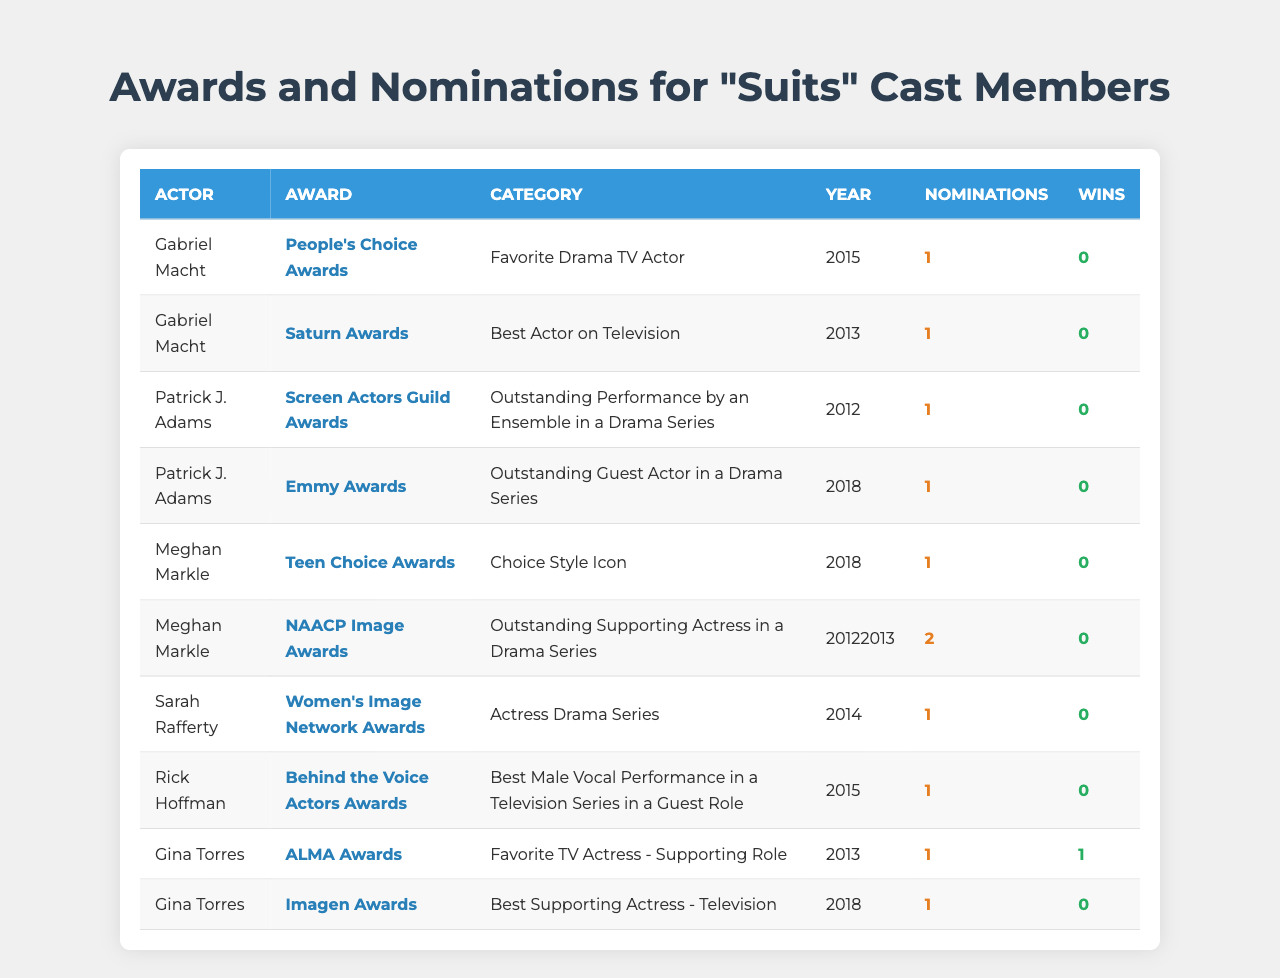What awards did Gabriel Macht receive nominations for? The table lists two awards for which Gabriel Macht received nominations: People's Choice Awards in 2015 for "Favorite Drama TV Actor" and Saturn Awards in 2013 for "Best Actor on Television."
Answer: People's Choice Awards, Saturn Awards How many total nominations did Meghan Markle receive? Meghan Markle received a total of 3 nominations: 1 from the Teen Choice Awards in 2018 and 2 from the NAACP Image Awards in 2012 and 2013. Thus, 1 + 2 = 3.
Answer: 3 Did any of the "Suits" cast members win an award? Yes, Gina Torres won 1 award from the ALMA Awards in 2013 for "Favorite TV Actress - Supporting Role."
Answer: Yes Which actor has the most awards listed in the table? Currently, only Gina Torres has 1 win, while all others have 0 wins. Thus, she has the most awards listed in the table even though it's only 1 win.
Answer: Gina Torres What is the average number of wins among the "Suits" cast members? All cast members except Gina Torres have 0 wins. As we count, there are a total of 7 awards listed, and the total win count is 1. Therefore, 1 win divided by 6 members equals an average of 1/6.
Answer: 0.17 How many years did Meghan Markle get nominated for the NAACP Image Awards? Meghan Markle received 2 nominations for the NAACP Image Awards in the years 2012 and 2013. Hence, she was nominated for a total of 2 years at this award.
Answer: 2 Which award did Rick Hoffman receive a nomination for in 2015? According to the table, Rick Hoffman received a nomination for the Behind the Voice Actors Awards for "Best Male Vocal Performance in a Television Series in a Guest Role" in 2015.
Answer: Behind the Voice Actors Awards Which actor had a nomination in 2014 and for what award? Sarah Rafferty had a nomination in 2014 at the Women's Image Network Awards for "Actress Drama Series." Therefore, she is the actor listed with a nomination in that year.
Answer: Sarah Rafferty, Women's Image Network Awards What is the difference in the number of nominations between Patrick J. Adams and Gabriel Macht? Both actors have 1 nomination each in the respective awards, which means the difference in their nominations is 0.
Answer: 0 How many total wins do the "Suits" cast members have? The table shows that only Gina Torres has a win (1 win), while all other actors have 0 wins, which totals to 1 win across the cast members.
Answer: 1 Which award category was the most common for the "Suits" cast nominations? The majority of nominations belong to various awards involving drama, specifically for acting. However, none has more than 1 occurrence. No specific category recurs; hence, they are diversified across acting roles.
Answer: None (diversified across categories) 